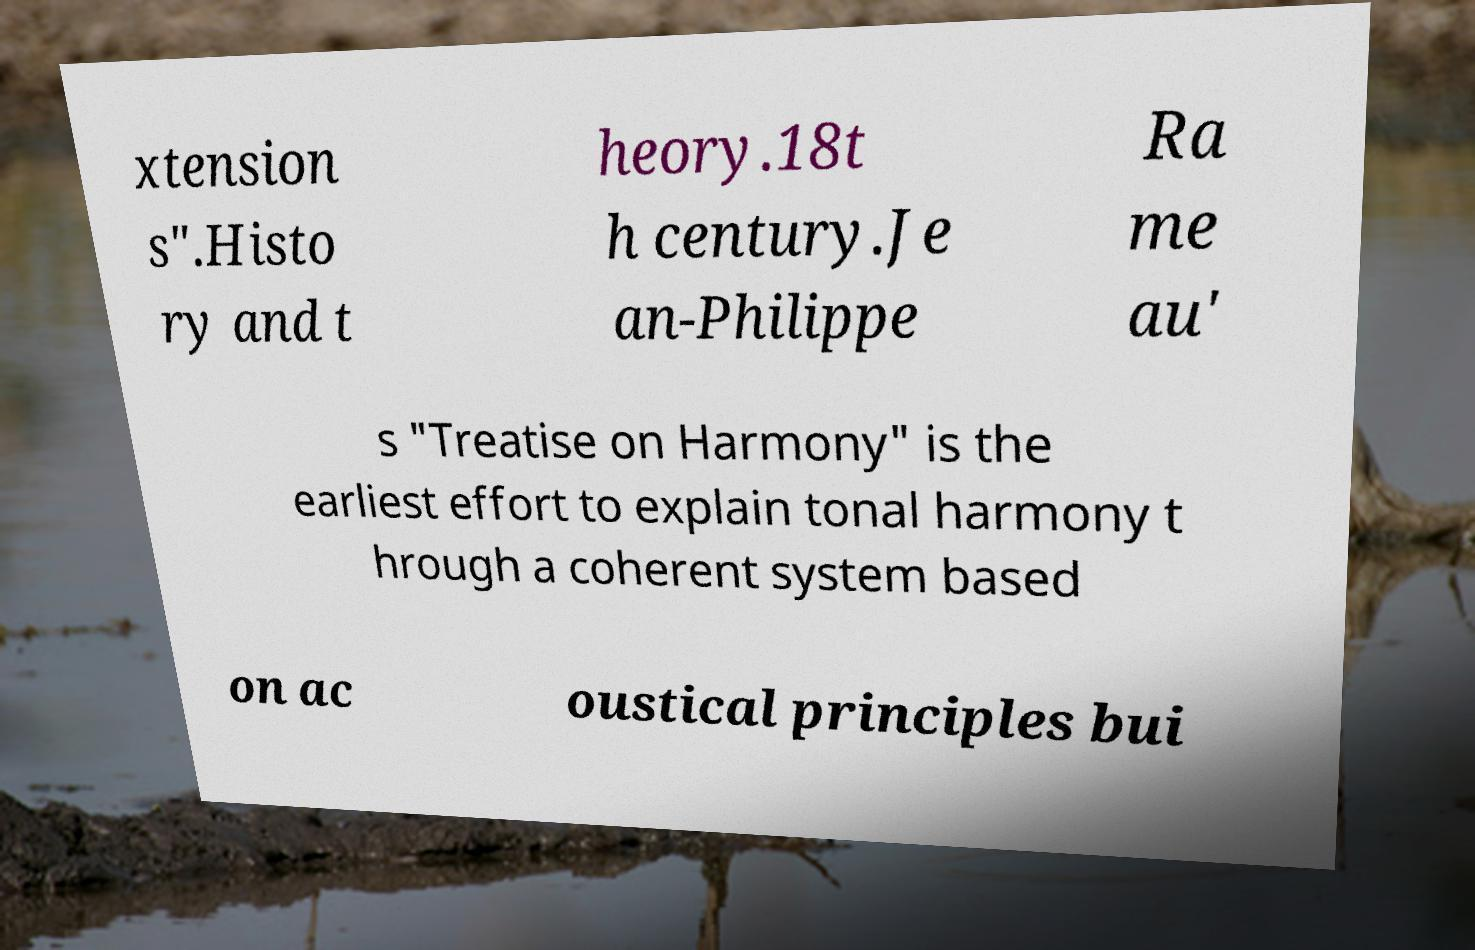I need the written content from this picture converted into text. Can you do that? xtension s".Histo ry and t heory.18t h century.Je an-Philippe Ra me au' s "Treatise on Harmony" is the earliest effort to explain tonal harmony t hrough a coherent system based on ac oustical principles bui 